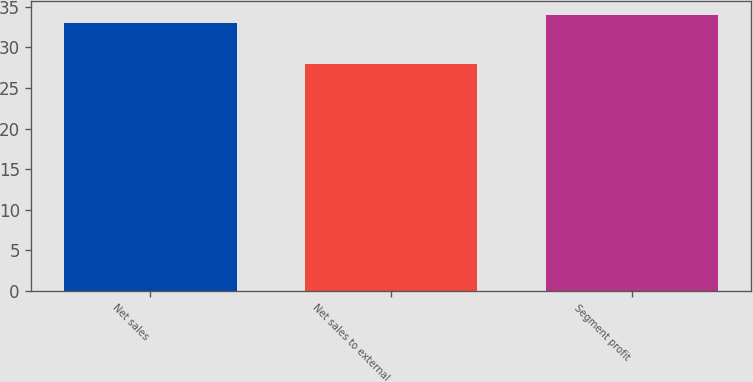Convert chart to OTSL. <chart><loc_0><loc_0><loc_500><loc_500><bar_chart><fcel>Net sales<fcel>Net sales to external<fcel>Segment profit<nl><fcel>33<fcel>28<fcel>34<nl></chart> 